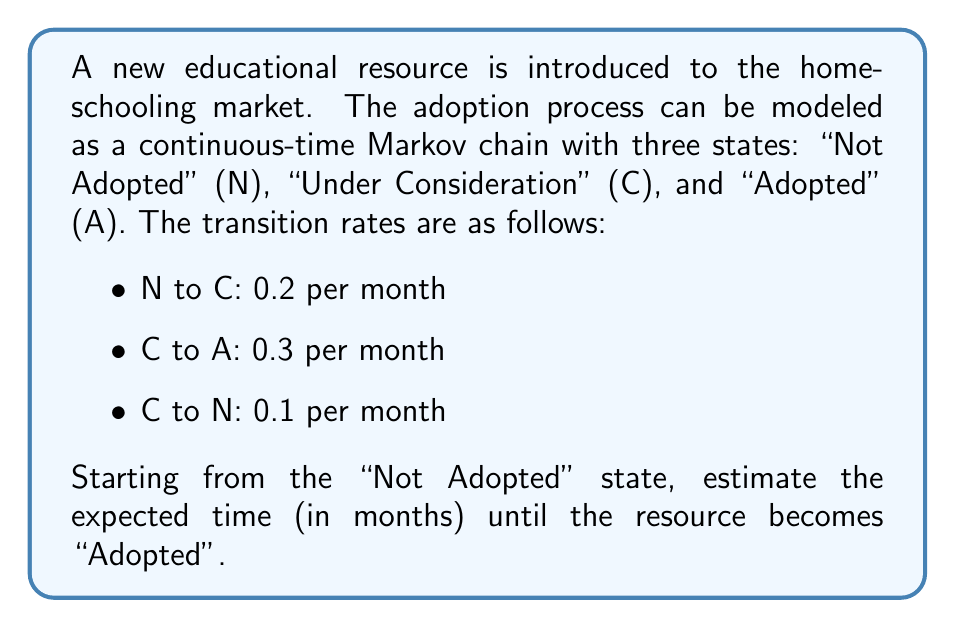Give your solution to this math problem. To solve this problem, we'll use the theory of absorbing Markov chains:

1) First, we need to set up the transition rate matrix Q:

   $$ Q = \begin{bmatrix}
   -0.2 & 0.2 & 0 \\
   0.1 & -0.4 & 0.3 \\
   0 & 0 & 0
   \end{bmatrix} $$

2) We can see that state A is absorbing. We need to focus on the transient states N and C.

3) Extract the submatrix T for the transient states:

   $$ T = \begin{bmatrix}
   -0.2 & 0.2 \\
   0.1 & -0.4
   \end{bmatrix} $$

4) The fundamental matrix N is given by $N = -T^{-1}$. Let's calculate it:

   $$ N = -\begin{bmatrix}
   -0.2 & 0.2 \\
   0.1 & -0.4
   \end{bmatrix}^{-1} = \begin{bmatrix}
   6 & 3 \\
   1.5 & 3
   \end{bmatrix} $$

5) The expected time to absorption starting from state i is given by the sum of the i-th row of N.

6) We start in state N (row 1), so the expected time to adoption is:

   $6 + 3 = 9$ months

Therefore, the expected time until the resource becomes adopted is 9 months.
Answer: 9 months 